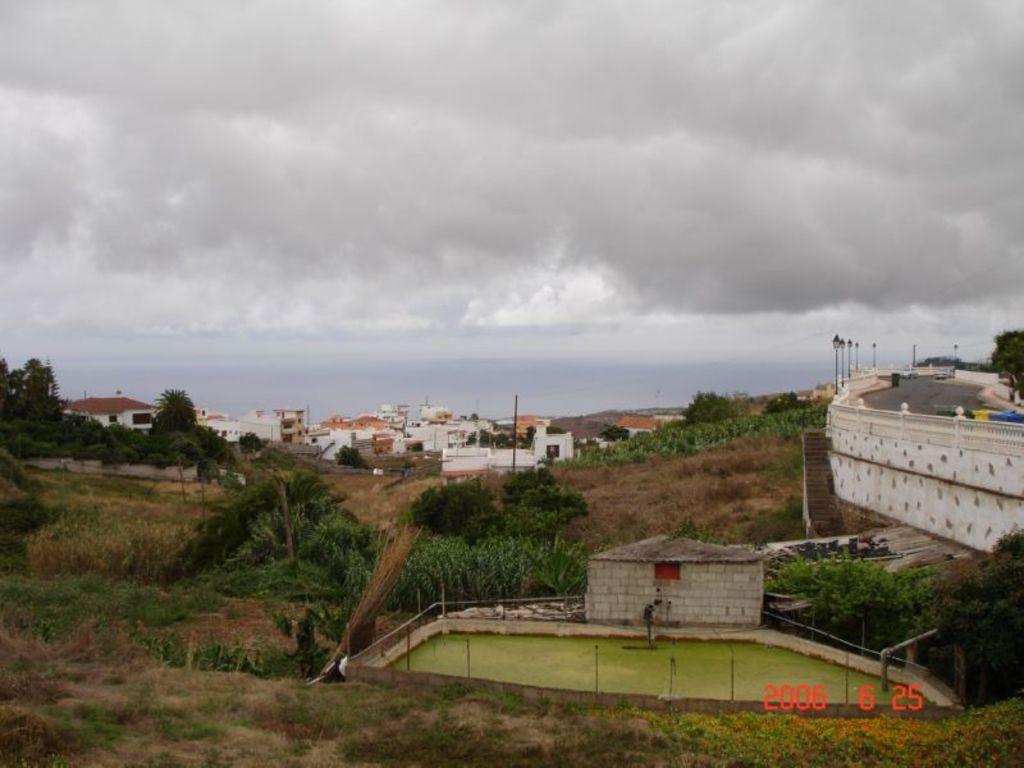Please provide a concise description of this image. In the picture there is most of the land covered with grass, trees and on the right side there is a small house, in front of that there is a water tank, beside that there is a road and in the background there are plenty of trees. 